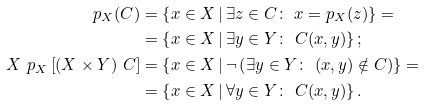<formula> <loc_0><loc_0><loc_500><loc_500>p _ { X } ( C ) & = \left \{ x \in X \, | \, \exists z \in C \colon \ x = p _ { X } ( z ) \right \} = \\ & = \left \{ x \in X \, | \, \exists y \in Y \colon \ C ( x , y ) \right \} ; \\ X \ p _ { X } \left [ ( X \times Y ) \ C \right ] & = \left \{ x \in X \, | \, \neg \left ( \exists y \in Y \colon \ ( x , y ) \notin C \right ) \right \} = \\ & = \left \{ x \in X \, | \, \forall y \in Y \colon \ C ( x , y ) \right \} .</formula> 